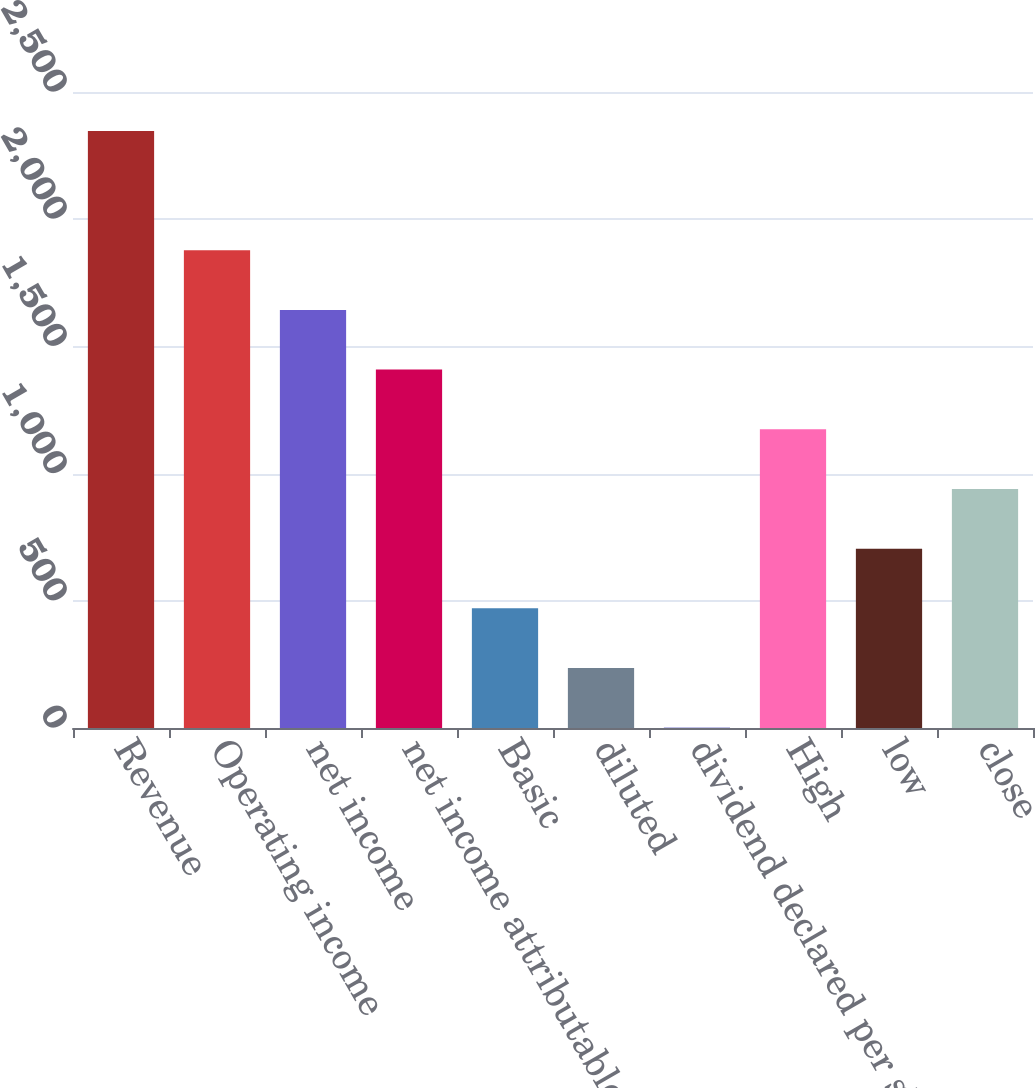Convert chart. <chart><loc_0><loc_0><loc_500><loc_500><bar_chart><fcel>Revenue<fcel>Operating income<fcel>net income<fcel>net income attributable to<fcel>Basic<fcel>diluted<fcel>dividend declared per share<fcel>High<fcel>low<fcel>close<nl><fcel>2347<fcel>1877.86<fcel>1643.3<fcel>1408.74<fcel>470.5<fcel>235.94<fcel>1.38<fcel>1174.18<fcel>705.06<fcel>939.62<nl></chart> 